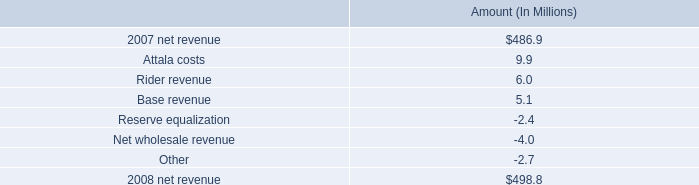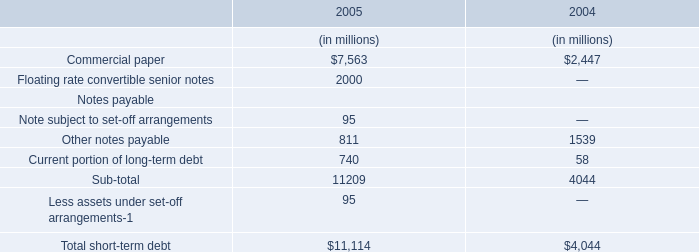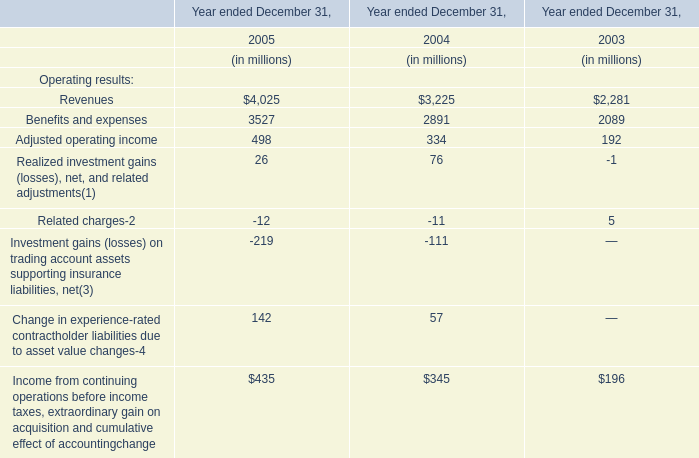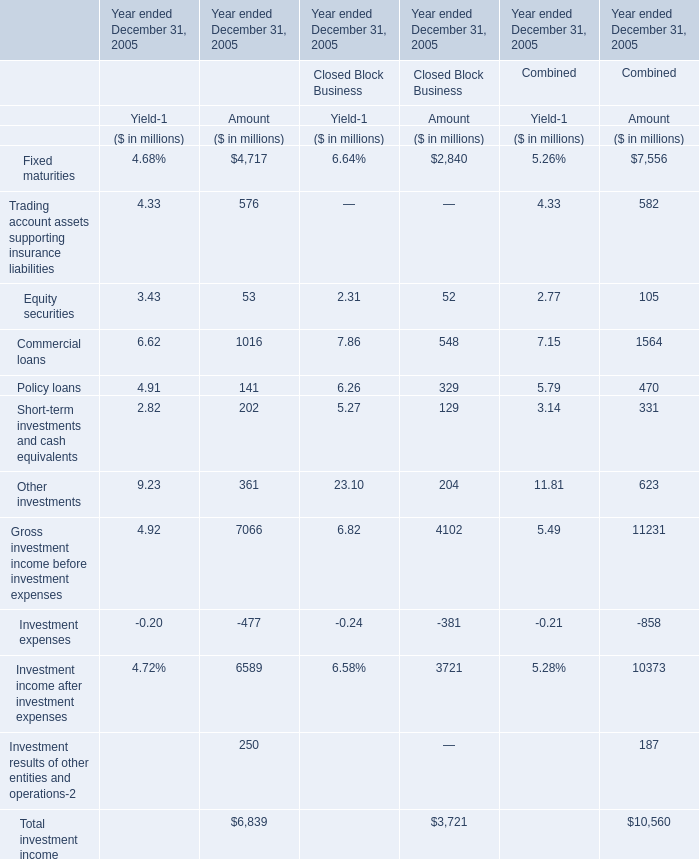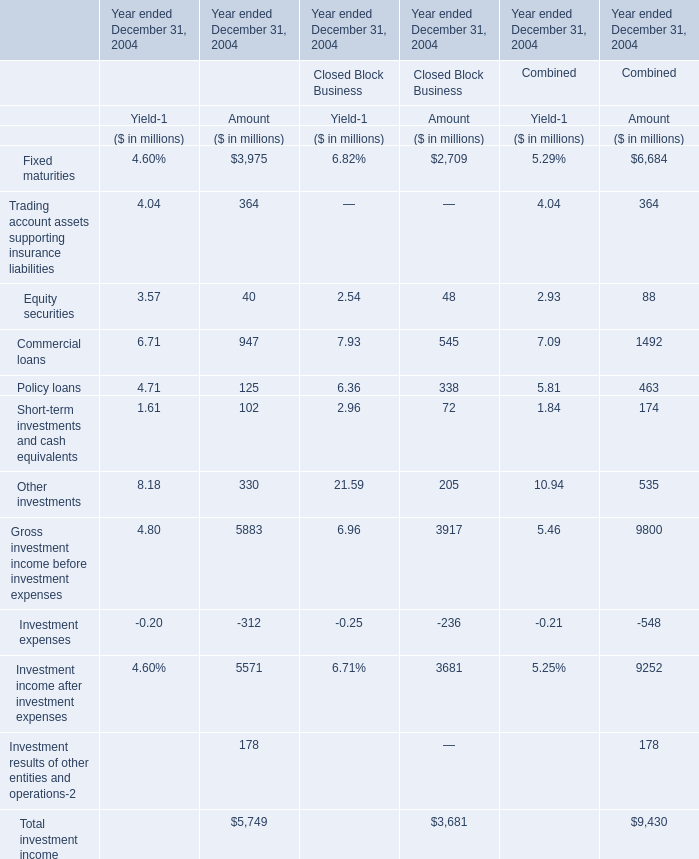What's the greatest value of Fixed maturities in 2005 for Amount? 
Computations: ((4717 + 2840) + 7556)
Answer: 15113.0. 